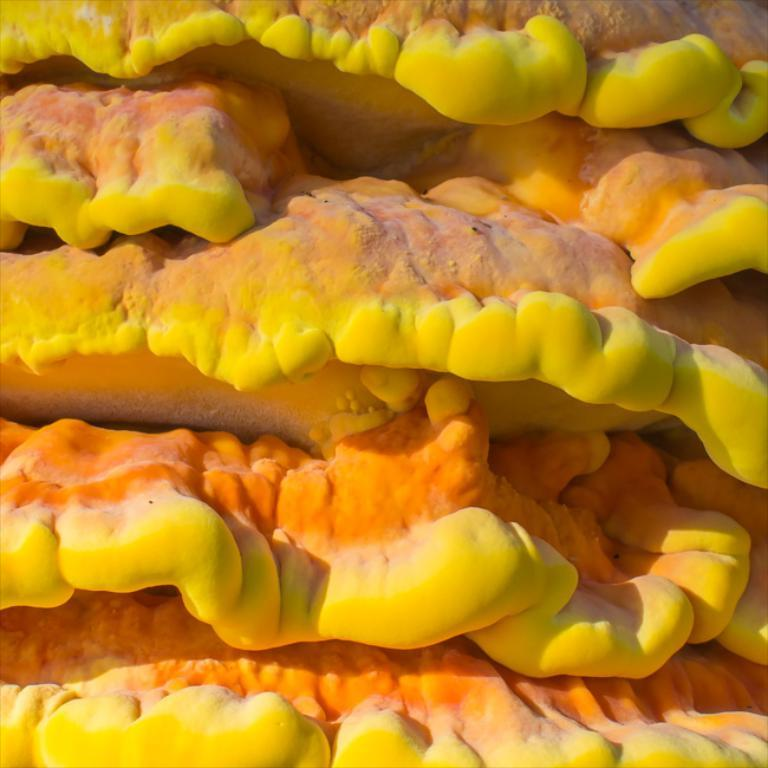What can be seen in the image? There is an object in the image. Can you describe the colors of the object? The object is yellow and orange. What invention is being demonstrated in the image? There is no invention being demonstrated in the image; it only shows an object with yellow and orange colors. Is the object in the image being used to yoke animals together? There is no indication in the image that the object is being used for yoking animals or any other specific purpose. 